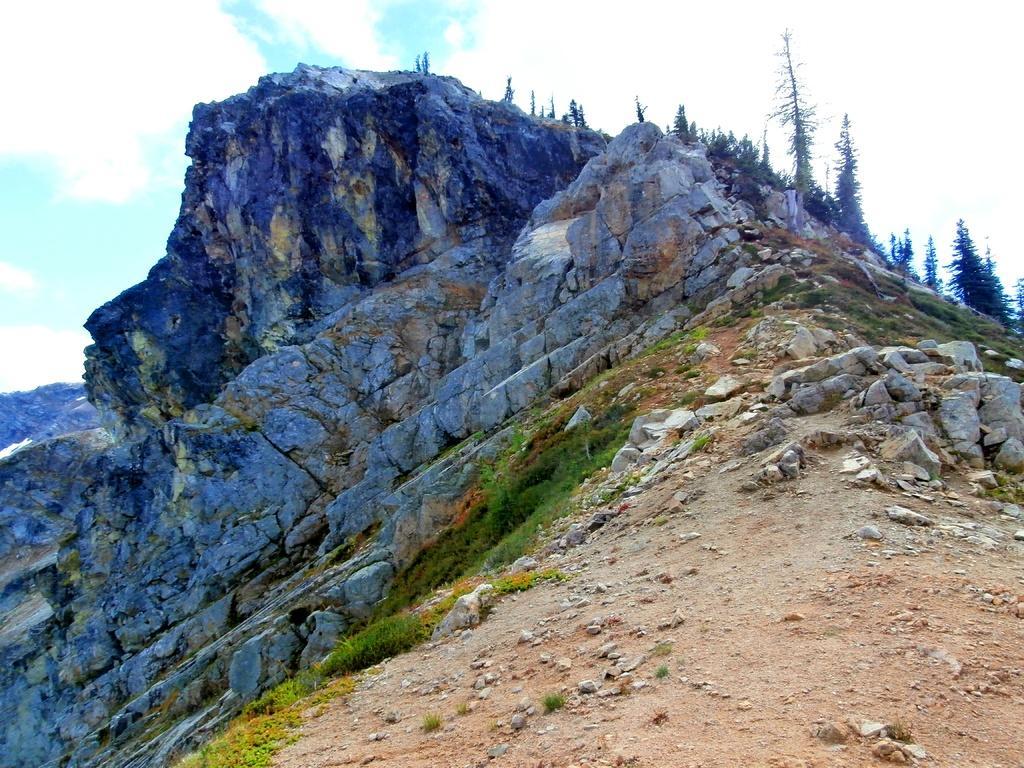Can you describe this image briefly? In the foreground I can see grass, mountains and trees. In the background I can see the sky. This image is taken may be on the mountain during a day. 